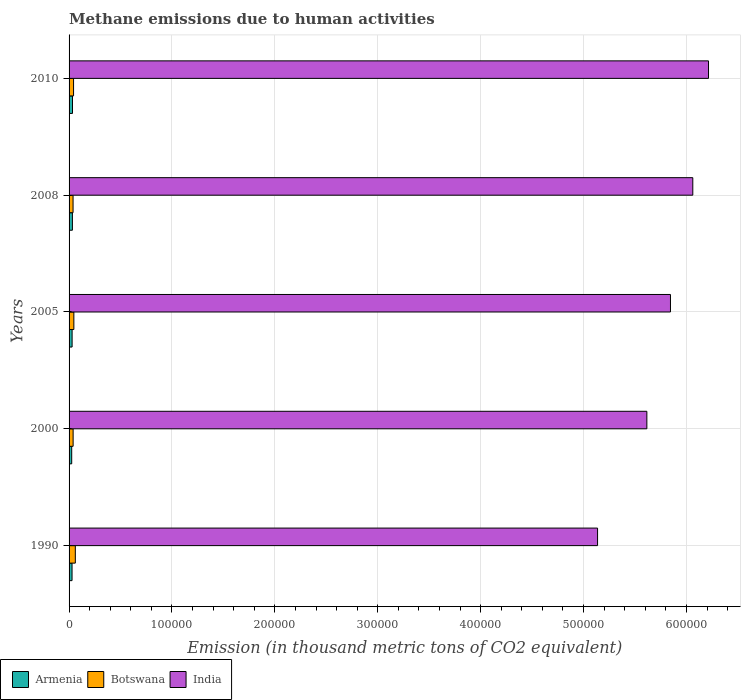How many different coloured bars are there?
Make the answer very short. 3. How many groups of bars are there?
Keep it short and to the point. 5. Are the number of bars per tick equal to the number of legend labels?
Offer a terse response. Yes. How many bars are there on the 4th tick from the top?
Provide a succinct answer. 3. How many bars are there on the 1st tick from the bottom?
Offer a terse response. 3. In how many cases, is the number of bars for a given year not equal to the number of legend labels?
Provide a succinct answer. 0. What is the amount of methane emitted in Armenia in 2008?
Make the answer very short. 3234.9. Across all years, what is the maximum amount of methane emitted in Armenia?
Your answer should be very brief. 3328.7. Across all years, what is the minimum amount of methane emitted in India?
Provide a succinct answer. 5.14e+05. In which year was the amount of methane emitted in Botswana maximum?
Provide a short and direct response. 1990. What is the total amount of methane emitted in Botswana in the graph?
Make the answer very short. 2.29e+04. What is the difference between the amount of methane emitted in Armenia in 2005 and that in 2010?
Offer a very short reply. -368.4. What is the difference between the amount of methane emitted in Armenia in 2010 and the amount of methane emitted in Botswana in 2008?
Provide a succinct answer. -546.8. What is the average amount of methane emitted in Botswana per year?
Your answer should be very brief. 4581.9. In the year 2005, what is the difference between the amount of methane emitted in India and amount of methane emitted in Armenia?
Offer a terse response. 5.82e+05. In how many years, is the amount of methane emitted in Armenia greater than 60000 thousand metric tons?
Your answer should be very brief. 0. What is the ratio of the amount of methane emitted in Armenia in 1990 to that in 2000?
Your answer should be very brief. 1.13. What is the difference between the highest and the second highest amount of methane emitted in India?
Your answer should be very brief. 1.53e+04. What is the difference between the highest and the lowest amount of methane emitted in India?
Provide a succinct answer. 1.08e+05. In how many years, is the amount of methane emitted in India greater than the average amount of methane emitted in India taken over all years?
Offer a very short reply. 3. Is the sum of the amount of methane emitted in Botswana in 2005 and 2010 greater than the maximum amount of methane emitted in Armenia across all years?
Your answer should be compact. Yes. What does the 1st bar from the bottom in 2005 represents?
Your answer should be very brief. Armenia. How many bars are there?
Offer a terse response. 15. How many years are there in the graph?
Provide a short and direct response. 5. What is the difference between two consecutive major ticks on the X-axis?
Provide a short and direct response. 1.00e+05. Are the values on the major ticks of X-axis written in scientific E-notation?
Your answer should be compact. No. Does the graph contain any zero values?
Your answer should be compact. No. Where does the legend appear in the graph?
Offer a terse response. Bottom left. What is the title of the graph?
Your answer should be very brief. Methane emissions due to human activities. What is the label or title of the X-axis?
Give a very brief answer. Emission (in thousand metric tons of CO2 equivalent). What is the Emission (in thousand metric tons of CO2 equivalent) in Armenia in 1990?
Give a very brief answer. 2890.7. What is the Emission (in thousand metric tons of CO2 equivalent) of Botswana in 1990?
Your answer should be very brief. 6074. What is the Emission (in thousand metric tons of CO2 equivalent) of India in 1990?
Give a very brief answer. 5.14e+05. What is the Emission (in thousand metric tons of CO2 equivalent) of Armenia in 2000?
Your response must be concise. 2565.3. What is the Emission (in thousand metric tons of CO2 equivalent) in Botswana in 2000?
Offer a terse response. 3941.1. What is the Emission (in thousand metric tons of CO2 equivalent) in India in 2000?
Your response must be concise. 5.62e+05. What is the Emission (in thousand metric tons of CO2 equivalent) of Armenia in 2005?
Make the answer very short. 2960.3. What is the Emission (in thousand metric tons of CO2 equivalent) in Botswana in 2005?
Keep it short and to the point. 4657.9. What is the Emission (in thousand metric tons of CO2 equivalent) of India in 2005?
Your answer should be compact. 5.84e+05. What is the Emission (in thousand metric tons of CO2 equivalent) in Armenia in 2008?
Ensure brevity in your answer.  3234.9. What is the Emission (in thousand metric tons of CO2 equivalent) of Botswana in 2008?
Provide a succinct answer. 3875.5. What is the Emission (in thousand metric tons of CO2 equivalent) in India in 2008?
Make the answer very short. 6.06e+05. What is the Emission (in thousand metric tons of CO2 equivalent) in Armenia in 2010?
Make the answer very short. 3328.7. What is the Emission (in thousand metric tons of CO2 equivalent) of Botswana in 2010?
Your answer should be compact. 4361. What is the Emission (in thousand metric tons of CO2 equivalent) of India in 2010?
Offer a terse response. 6.21e+05. Across all years, what is the maximum Emission (in thousand metric tons of CO2 equivalent) of Armenia?
Your answer should be compact. 3328.7. Across all years, what is the maximum Emission (in thousand metric tons of CO2 equivalent) of Botswana?
Your answer should be compact. 6074. Across all years, what is the maximum Emission (in thousand metric tons of CO2 equivalent) of India?
Offer a very short reply. 6.21e+05. Across all years, what is the minimum Emission (in thousand metric tons of CO2 equivalent) of Armenia?
Offer a terse response. 2565.3. Across all years, what is the minimum Emission (in thousand metric tons of CO2 equivalent) of Botswana?
Give a very brief answer. 3875.5. Across all years, what is the minimum Emission (in thousand metric tons of CO2 equivalent) in India?
Your response must be concise. 5.14e+05. What is the total Emission (in thousand metric tons of CO2 equivalent) of Armenia in the graph?
Keep it short and to the point. 1.50e+04. What is the total Emission (in thousand metric tons of CO2 equivalent) in Botswana in the graph?
Give a very brief answer. 2.29e+04. What is the total Emission (in thousand metric tons of CO2 equivalent) of India in the graph?
Keep it short and to the point. 2.89e+06. What is the difference between the Emission (in thousand metric tons of CO2 equivalent) of Armenia in 1990 and that in 2000?
Provide a short and direct response. 325.4. What is the difference between the Emission (in thousand metric tons of CO2 equivalent) in Botswana in 1990 and that in 2000?
Ensure brevity in your answer.  2132.9. What is the difference between the Emission (in thousand metric tons of CO2 equivalent) in India in 1990 and that in 2000?
Offer a terse response. -4.79e+04. What is the difference between the Emission (in thousand metric tons of CO2 equivalent) of Armenia in 1990 and that in 2005?
Make the answer very short. -69.6. What is the difference between the Emission (in thousand metric tons of CO2 equivalent) of Botswana in 1990 and that in 2005?
Keep it short and to the point. 1416.1. What is the difference between the Emission (in thousand metric tons of CO2 equivalent) in India in 1990 and that in 2005?
Provide a short and direct response. -7.09e+04. What is the difference between the Emission (in thousand metric tons of CO2 equivalent) in Armenia in 1990 and that in 2008?
Your answer should be compact. -344.2. What is the difference between the Emission (in thousand metric tons of CO2 equivalent) in Botswana in 1990 and that in 2008?
Provide a succinct answer. 2198.5. What is the difference between the Emission (in thousand metric tons of CO2 equivalent) of India in 1990 and that in 2008?
Offer a terse response. -9.26e+04. What is the difference between the Emission (in thousand metric tons of CO2 equivalent) of Armenia in 1990 and that in 2010?
Your answer should be very brief. -438. What is the difference between the Emission (in thousand metric tons of CO2 equivalent) of Botswana in 1990 and that in 2010?
Make the answer very short. 1713. What is the difference between the Emission (in thousand metric tons of CO2 equivalent) in India in 1990 and that in 2010?
Offer a very short reply. -1.08e+05. What is the difference between the Emission (in thousand metric tons of CO2 equivalent) in Armenia in 2000 and that in 2005?
Your answer should be compact. -395. What is the difference between the Emission (in thousand metric tons of CO2 equivalent) in Botswana in 2000 and that in 2005?
Offer a very short reply. -716.8. What is the difference between the Emission (in thousand metric tons of CO2 equivalent) of India in 2000 and that in 2005?
Your answer should be very brief. -2.29e+04. What is the difference between the Emission (in thousand metric tons of CO2 equivalent) of Armenia in 2000 and that in 2008?
Ensure brevity in your answer.  -669.6. What is the difference between the Emission (in thousand metric tons of CO2 equivalent) in Botswana in 2000 and that in 2008?
Offer a terse response. 65.6. What is the difference between the Emission (in thousand metric tons of CO2 equivalent) of India in 2000 and that in 2008?
Make the answer very short. -4.46e+04. What is the difference between the Emission (in thousand metric tons of CO2 equivalent) of Armenia in 2000 and that in 2010?
Your answer should be very brief. -763.4. What is the difference between the Emission (in thousand metric tons of CO2 equivalent) of Botswana in 2000 and that in 2010?
Your answer should be very brief. -419.9. What is the difference between the Emission (in thousand metric tons of CO2 equivalent) in India in 2000 and that in 2010?
Ensure brevity in your answer.  -5.99e+04. What is the difference between the Emission (in thousand metric tons of CO2 equivalent) of Armenia in 2005 and that in 2008?
Ensure brevity in your answer.  -274.6. What is the difference between the Emission (in thousand metric tons of CO2 equivalent) of Botswana in 2005 and that in 2008?
Provide a succinct answer. 782.4. What is the difference between the Emission (in thousand metric tons of CO2 equivalent) of India in 2005 and that in 2008?
Offer a very short reply. -2.17e+04. What is the difference between the Emission (in thousand metric tons of CO2 equivalent) of Armenia in 2005 and that in 2010?
Provide a succinct answer. -368.4. What is the difference between the Emission (in thousand metric tons of CO2 equivalent) in Botswana in 2005 and that in 2010?
Offer a very short reply. 296.9. What is the difference between the Emission (in thousand metric tons of CO2 equivalent) in India in 2005 and that in 2010?
Keep it short and to the point. -3.70e+04. What is the difference between the Emission (in thousand metric tons of CO2 equivalent) of Armenia in 2008 and that in 2010?
Keep it short and to the point. -93.8. What is the difference between the Emission (in thousand metric tons of CO2 equivalent) of Botswana in 2008 and that in 2010?
Provide a succinct answer. -485.5. What is the difference between the Emission (in thousand metric tons of CO2 equivalent) of India in 2008 and that in 2010?
Keep it short and to the point. -1.53e+04. What is the difference between the Emission (in thousand metric tons of CO2 equivalent) of Armenia in 1990 and the Emission (in thousand metric tons of CO2 equivalent) of Botswana in 2000?
Offer a very short reply. -1050.4. What is the difference between the Emission (in thousand metric tons of CO2 equivalent) in Armenia in 1990 and the Emission (in thousand metric tons of CO2 equivalent) in India in 2000?
Keep it short and to the point. -5.59e+05. What is the difference between the Emission (in thousand metric tons of CO2 equivalent) of Botswana in 1990 and the Emission (in thousand metric tons of CO2 equivalent) of India in 2000?
Give a very brief answer. -5.55e+05. What is the difference between the Emission (in thousand metric tons of CO2 equivalent) of Armenia in 1990 and the Emission (in thousand metric tons of CO2 equivalent) of Botswana in 2005?
Ensure brevity in your answer.  -1767.2. What is the difference between the Emission (in thousand metric tons of CO2 equivalent) of Armenia in 1990 and the Emission (in thousand metric tons of CO2 equivalent) of India in 2005?
Keep it short and to the point. -5.82e+05. What is the difference between the Emission (in thousand metric tons of CO2 equivalent) of Botswana in 1990 and the Emission (in thousand metric tons of CO2 equivalent) of India in 2005?
Ensure brevity in your answer.  -5.78e+05. What is the difference between the Emission (in thousand metric tons of CO2 equivalent) in Armenia in 1990 and the Emission (in thousand metric tons of CO2 equivalent) in Botswana in 2008?
Ensure brevity in your answer.  -984.8. What is the difference between the Emission (in thousand metric tons of CO2 equivalent) of Armenia in 1990 and the Emission (in thousand metric tons of CO2 equivalent) of India in 2008?
Provide a short and direct response. -6.03e+05. What is the difference between the Emission (in thousand metric tons of CO2 equivalent) of Botswana in 1990 and the Emission (in thousand metric tons of CO2 equivalent) of India in 2008?
Provide a succinct answer. -6.00e+05. What is the difference between the Emission (in thousand metric tons of CO2 equivalent) in Armenia in 1990 and the Emission (in thousand metric tons of CO2 equivalent) in Botswana in 2010?
Make the answer very short. -1470.3. What is the difference between the Emission (in thousand metric tons of CO2 equivalent) in Armenia in 1990 and the Emission (in thousand metric tons of CO2 equivalent) in India in 2010?
Your answer should be very brief. -6.19e+05. What is the difference between the Emission (in thousand metric tons of CO2 equivalent) of Botswana in 1990 and the Emission (in thousand metric tons of CO2 equivalent) of India in 2010?
Make the answer very short. -6.15e+05. What is the difference between the Emission (in thousand metric tons of CO2 equivalent) of Armenia in 2000 and the Emission (in thousand metric tons of CO2 equivalent) of Botswana in 2005?
Your response must be concise. -2092.6. What is the difference between the Emission (in thousand metric tons of CO2 equivalent) of Armenia in 2000 and the Emission (in thousand metric tons of CO2 equivalent) of India in 2005?
Offer a terse response. -5.82e+05. What is the difference between the Emission (in thousand metric tons of CO2 equivalent) in Botswana in 2000 and the Emission (in thousand metric tons of CO2 equivalent) in India in 2005?
Give a very brief answer. -5.81e+05. What is the difference between the Emission (in thousand metric tons of CO2 equivalent) of Armenia in 2000 and the Emission (in thousand metric tons of CO2 equivalent) of Botswana in 2008?
Provide a succinct answer. -1310.2. What is the difference between the Emission (in thousand metric tons of CO2 equivalent) in Armenia in 2000 and the Emission (in thousand metric tons of CO2 equivalent) in India in 2008?
Your answer should be compact. -6.04e+05. What is the difference between the Emission (in thousand metric tons of CO2 equivalent) in Botswana in 2000 and the Emission (in thousand metric tons of CO2 equivalent) in India in 2008?
Your answer should be compact. -6.02e+05. What is the difference between the Emission (in thousand metric tons of CO2 equivalent) in Armenia in 2000 and the Emission (in thousand metric tons of CO2 equivalent) in Botswana in 2010?
Give a very brief answer. -1795.7. What is the difference between the Emission (in thousand metric tons of CO2 equivalent) in Armenia in 2000 and the Emission (in thousand metric tons of CO2 equivalent) in India in 2010?
Your answer should be very brief. -6.19e+05. What is the difference between the Emission (in thousand metric tons of CO2 equivalent) in Botswana in 2000 and the Emission (in thousand metric tons of CO2 equivalent) in India in 2010?
Offer a terse response. -6.18e+05. What is the difference between the Emission (in thousand metric tons of CO2 equivalent) in Armenia in 2005 and the Emission (in thousand metric tons of CO2 equivalent) in Botswana in 2008?
Make the answer very short. -915.2. What is the difference between the Emission (in thousand metric tons of CO2 equivalent) of Armenia in 2005 and the Emission (in thousand metric tons of CO2 equivalent) of India in 2008?
Your answer should be compact. -6.03e+05. What is the difference between the Emission (in thousand metric tons of CO2 equivalent) in Botswana in 2005 and the Emission (in thousand metric tons of CO2 equivalent) in India in 2008?
Give a very brief answer. -6.02e+05. What is the difference between the Emission (in thousand metric tons of CO2 equivalent) in Armenia in 2005 and the Emission (in thousand metric tons of CO2 equivalent) in Botswana in 2010?
Ensure brevity in your answer.  -1400.7. What is the difference between the Emission (in thousand metric tons of CO2 equivalent) of Armenia in 2005 and the Emission (in thousand metric tons of CO2 equivalent) of India in 2010?
Offer a terse response. -6.19e+05. What is the difference between the Emission (in thousand metric tons of CO2 equivalent) in Botswana in 2005 and the Emission (in thousand metric tons of CO2 equivalent) in India in 2010?
Provide a succinct answer. -6.17e+05. What is the difference between the Emission (in thousand metric tons of CO2 equivalent) in Armenia in 2008 and the Emission (in thousand metric tons of CO2 equivalent) in Botswana in 2010?
Offer a very short reply. -1126.1. What is the difference between the Emission (in thousand metric tons of CO2 equivalent) of Armenia in 2008 and the Emission (in thousand metric tons of CO2 equivalent) of India in 2010?
Offer a very short reply. -6.18e+05. What is the difference between the Emission (in thousand metric tons of CO2 equivalent) of Botswana in 2008 and the Emission (in thousand metric tons of CO2 equivalent) of India in 2010?
Keep it short and to the point. -6.18e+05. What is the average Emission (in thousand metric tons of CO2 equivalent) of Armenia per year?
Keep it short and to the point. 2995.98. What is the average Emission (in thousand metric tons of CO2 equivalent) in Botswana per year?
Your answer should be compact. 4581.9. What is the average Emission (in thousand metric tons of CO2 equivalent) of India per year?
Offer a very short reply. 5.77e+05. In the year 1990, what is the difference between the Emission (in thousand metric tons of CO2 equivalent) in Armenia and Emission (in thousand metric tons of CO2 equivalent) in Botswana?
Keep it short and to the point. -3183.3. In the year 1990, what is the difference between the Emission (in thousand metric tons of CO2 equivalent) in Armenia and Emission (in thousand metric tons of CO2 equivalent) in India?
Make the answer very short. -5.11e+05. In the year 1990, what is the difference between the Emission (in thousand metric tons of CO2 equivalent) of Botswana and Emission (in thousand metric tons of CO2 equivalent) of India?
Make the answer very short. -5.08e+05. In the year 2000, what is the difference between the Emission (in thousand metric tons of CO2 equivalent) in Armenia and Emission (in thousand metric tons of CO2 equivalent) in Botswana?
Provide a short and direct response. -1375.8. In the year 2000, what is the difference between the Emission (in thousand metric tons of CO2 equivalent) of Armenia and Emission (in thousand metric tons of CO2 equivalent) of India?
Your answer should be compact. -5.59e+05. In the year 2000, what is the difference between the Emission (in thousand metric tons of CO2 equivalent) of Botswana and Emission (in thousand metric tons of CO2 equivalent) of India?
Provide a short and direct response. -5.58e+05. In the year 2005, what is the difference between the Emission (in thousand metric tons of CO2 equivalent) of Armenia and Emission (in thousand metric tons of CO2 equivalent) of Botswana?
Your answer should be compact. -1697.6. In the year 2005, what is the difference between the Emission (in thousand metric tons of CO2 equivalent) of Armenia and Emission (in thousand metric tons of CO2 equivalent) of India?
Provide a short and direct response. -5.82e+05. In the year 2005, what is the difference between the Emission (in thousand metric tons of CO2 equivalent) of Botswana and Emission (in thousand metric tons of CO2 equivalent) of India?
Keep it short and to the point. -5.80e+05. In the year 2008, what is the difference between the Emission (in thousand metric tons of CO2 equivalent) of Armenia and Emission (in thousand metric tons of CO2 equivalent) of Botswana?
Your answer should be compact. -640.6. In the year 2008, what is the difference between the Emission (in thousand metric tons of CO2 equivalent) of Armenia and Emission (in thousand metric tons of CO2 equivalent) of India?
Your response must be concise. -6.03e+05. In the year 2008, what is the difference between the Emission (in thousand metric tons of CO2 equivalent) in Botswana and Emission (in thousand metric tons of CO2 equivalent) in India?
Keep it short and to the point. -6.02e+05. In the year 2010, what is the difference between the Emission (in thousand metric tons of CO2 equivalent) in Armenia and Emission (in thousand metric tons of CO2 equivalent) in Botswana?
Your response must be concise. -1032.3. In the year 2010, what is the difference between the Emission (in thousand metric tons of CO2 equivalent) in Armenia and Emission (in thousand metric tons of CO2 equivalent) in India?
Your answer should be very brief. -6.18e+05. In the year 2010, what is the difference between the Emission (in thousand metric tons of CO2 equivalent) in Botswana and Emission (in thousand metric tons of CO2 equivalent) in India?
Give a very brief answer. -6.17e+05. What is the ratio of the Emission (in thousand metric tons of CO2 equivalent) in Armenia in 1990 to that in 2000?
Provide a short and direct response. 1.13. What is the ratio of the Emission (in thousand metric tons of CO2 equivalent) in Botswana in 1990 to that in 2000?
Give a very brief answer. 1.54. What is the ratio of the Emission (in thousand metric tons of CO2 equivalent) in India in 1990 to that in 2000?
Provide a succinct answer. 0.91. What is the ratio of the Emission (in thousand metric tons of CO2 equivalent) in Armenia in 1990 to that in 2005?
Give a very brief answer. 0.98. What is the ratio of the Emission (in thousand metric tons of CO2 equivalent) of Botswana in 1990 to that in 2005?
Keep it short and to the point. 1.3. What is the ratio of the Emission (in thousand metric tons of CO2 equivalent) of India in 1990 to that in 2005?
Give a very brief answer. 0.88. What is the ratio of the Emission (in thousand metric tons of CO2 equivalent) of Armenia in 1990 to that in 2008?
Offer a very short reply. 0.89. What is the ratio of the Emission (in thousand metric tons of CO2 equivalent) of Botswana in 1990 to that in 2008?
Provide a short and direct response. 1.57. What is the ratio of the Emission (in thousand metric tons of CO2 equivalent) of India in 1990 to that in 2008?
Offer a very short reply. 0.85. What is the ratio of the Emission (in thousand metric tons of CO2 equivalent) of Armenia in 1990 to that in 2010?
Provide a succinct answer. 0.87. What is the ratio of the Emission (in thousand metric tons of CO2 equivalent) in Botswana in 1990 to that in 2010?
Give a very brief answer. 1.39. What is the ratio of the Emission (in thousand metric tons of CO2 equivalent) in India in 1990 to that in 2010?
Offer a very short reply. 0.83. What is the ratio of the Emission (in thousand metric tons of CO2 equivalent) of Armenia in 2000 to that in 2005?
Provide a short and direct response. 0.87. What is the ratio of the Emission (in thousand metric tons of CO2 equivalent) of Botswana in 2000 to that in 2005?
Ensure brevity in your answer.  0.85. What is the ratio of the Emission (in thousand metric tons of CO2 equivalent) of India in 2000 to that in 2005?
Provide a succinct answer. 0.96. What is the ratio of the Emission (in thousand metric tons of CO2 equivalent) in Armenia in 2000 to that in 2008?
Keep it short and to the point. 0.79. What is the ratio of the Emission (in thousand metric tons of CO2 equivalent) in Botswana in 2000 to that in 2008?
Your answer should be very brief. 1.02. What is the ratio of the Emission (in thousand metric tons of CO2 equivalent) of India in 2000 to that in 2008?
Ensure brevity in your answer.  0.93. What is the ratio of the Emission (in thousand metric tons of CO2 equivalent) of Armenia in 2000 to that in 2010?
Your response must be concise. 0.77. What is the ratio of the Emission (in thousand metric tons of CO2 equivalent) of Botswana in 2000 to that in 2010?
Provide a succinct answer. 0.9. What is the ratio of the Emission (in thousand metric tons of CO2 equivalent) of India in 2000 to that in 2010?
Your answer should be very brief. 0.9. What is the ratio of the Emission (in thousand metric tons of CO2 equivalent) of Armenia in 2005 to that in 2008?
Your answer should be very brief. 0.92. What is the ratio of the Emission (in thousand metric tons of CO2 equivalent) of Botswana in 2005 to that in 2008?
Provide a short and direct response. 1.2. What is the ratio of the Emission (in thousand metric tons of CO2 equivalent) of India in 2005 to that in 2008?
Offer a very short reply. 0.96. What is the ratio of the Emission (in thousand metric tons of CO2 equivalent) of Armenia in 2005 to that in 2010?
Offer a very short reply. 0.89. What is the ratio of the Emission (in thousand metric tons of CO2 equivalent) in Botswana in 2005 to that in 2010?
Ensure brevity in your answer.  1.07. What is the ratio of the Emission (in thousand metric tons of CO2 equivalent) in India in 2005 to that in 2010?
Your response must be concise. 0.94. What is the ratio of the Emission (in thousand metric tons of CO2 equivalent) in Armenia in 2008 to that in 2010?
Your response must be concise. 0.97. What is the ratio of the Emission (in thousand metric tons of CO2 equivalent) in Botswana in 2008 to that in 2010?
Your answer should be very brief. 0.89. What is the ratio of the Emission (in thousand metric tons of CO2 equivalent) in India in 2008 to that in 2010?
Your answer should be very brief. 0.98. What is the difference between the highest and the second highest Emission (in thousand metric tons of CO2 equivalent) of Armenia?
Your answer should be compact. 93.8. What is the difference between the highest and the second highest Emission (in thousand metric tons of CO2 equivalent) of Botswana?
Offer a terse response. 1416.1. What is the difference between the highest and the second highest Emission (in thousand metric tons of CO2 equivalent) in India?
Your answer should be very brief. 1.53e+04. What is the difference between the highest and the lowest Emission (in thousand metric tons of CO2 equivalent) of Armenia?
Give a very brief answer. 763.4. What is the difference between the highest and the lowest Emission (in thousand metric tons of CO2 equivalent) of Botswana?
Your answer should be very brief. 2198.5. What is the difference between the highest and the lowest Emission (in thousand metric tons of CO2 equivalent) of India?
Provide a short and direct response. 1.08e+05. 